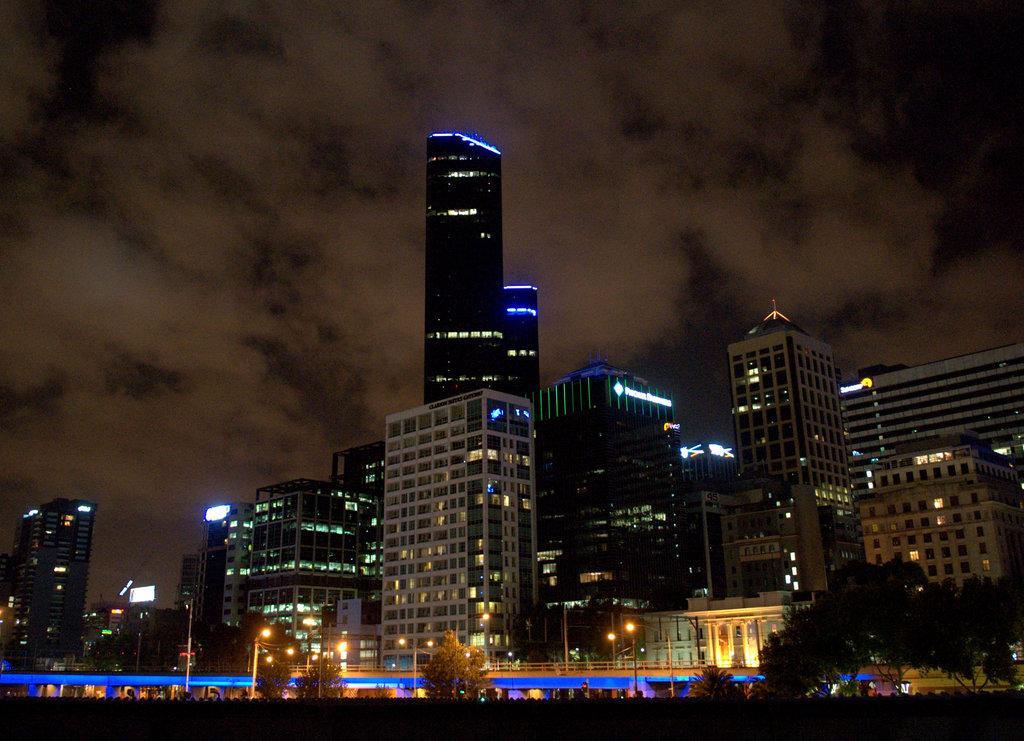Could you give a brief overview of what you see in this image? In this image at the bottom the image is dark but we can see trees and poles. In the background there are buildings, lights, windows, light poles, hoardings, trees and clouds in the sky. 